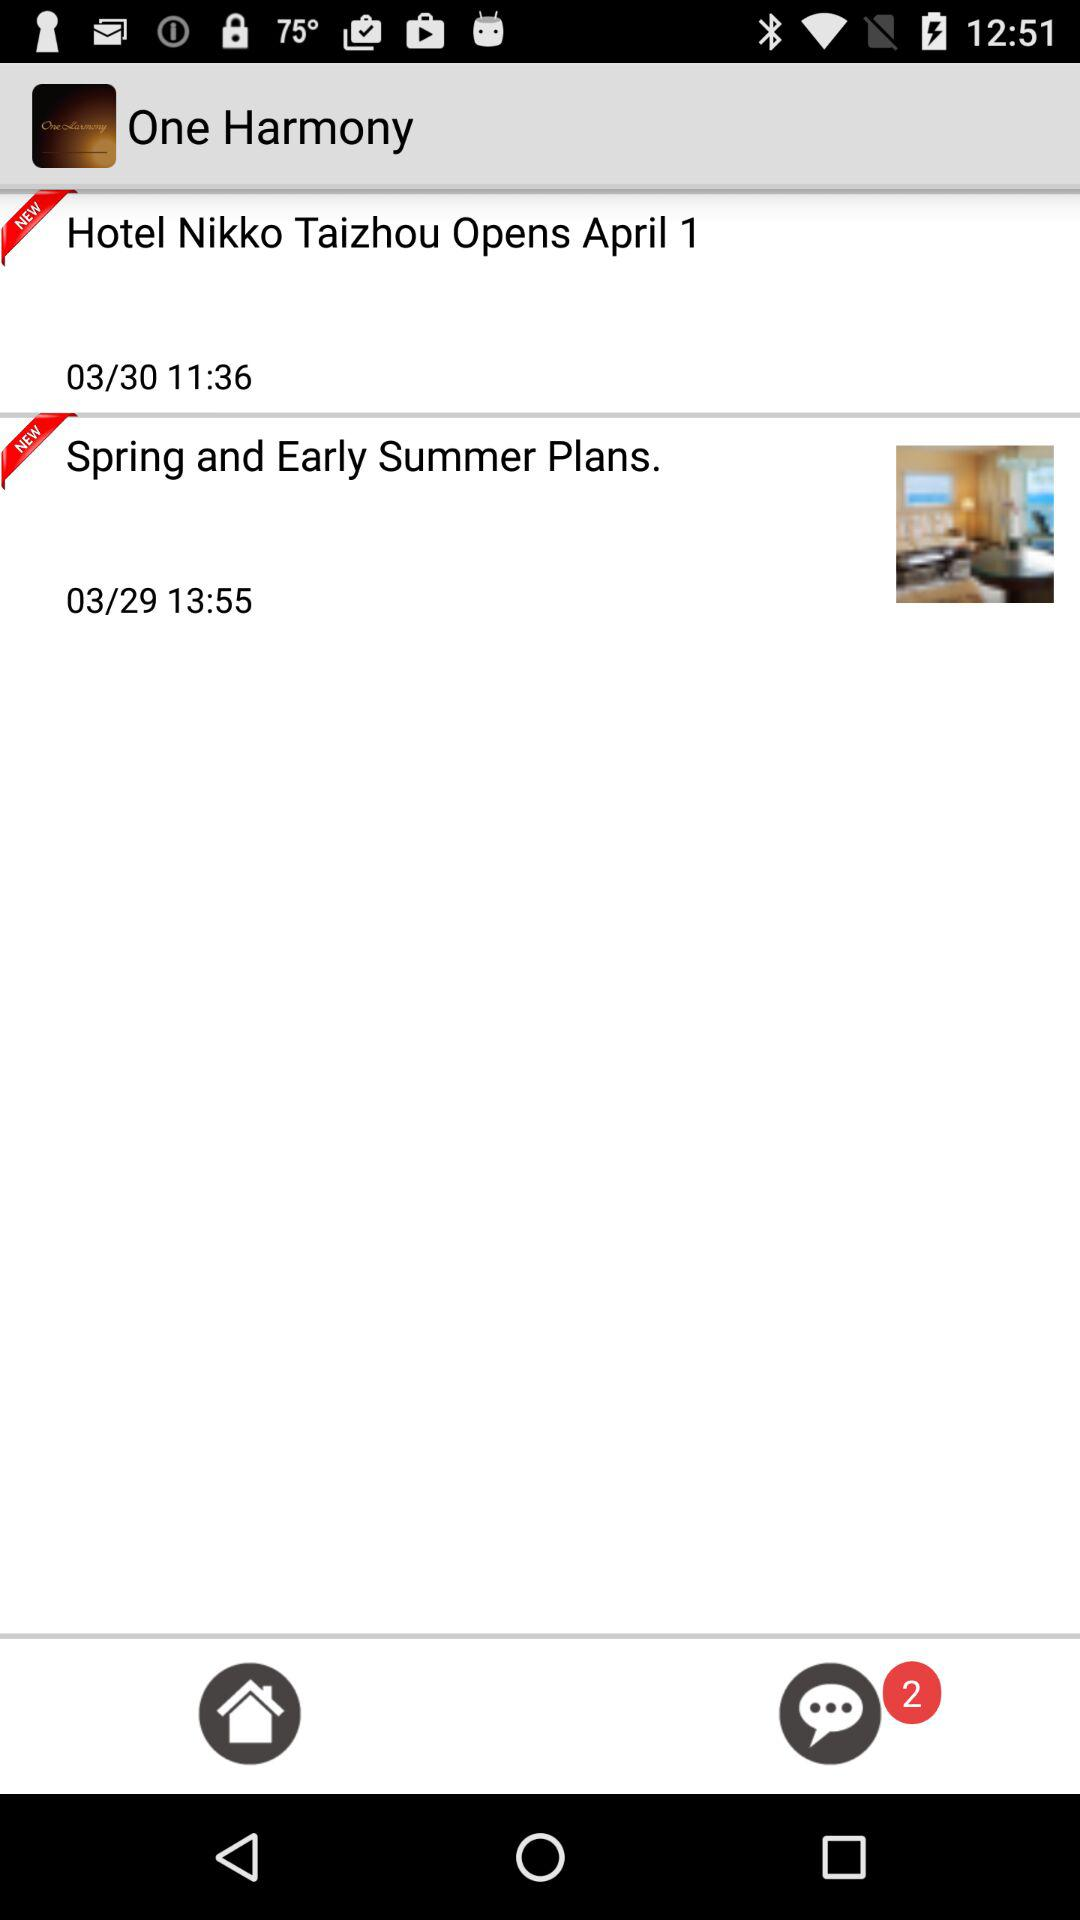What is the date of "Hotel Nikko Taizhou Opens April 1"? The date is March 30. 